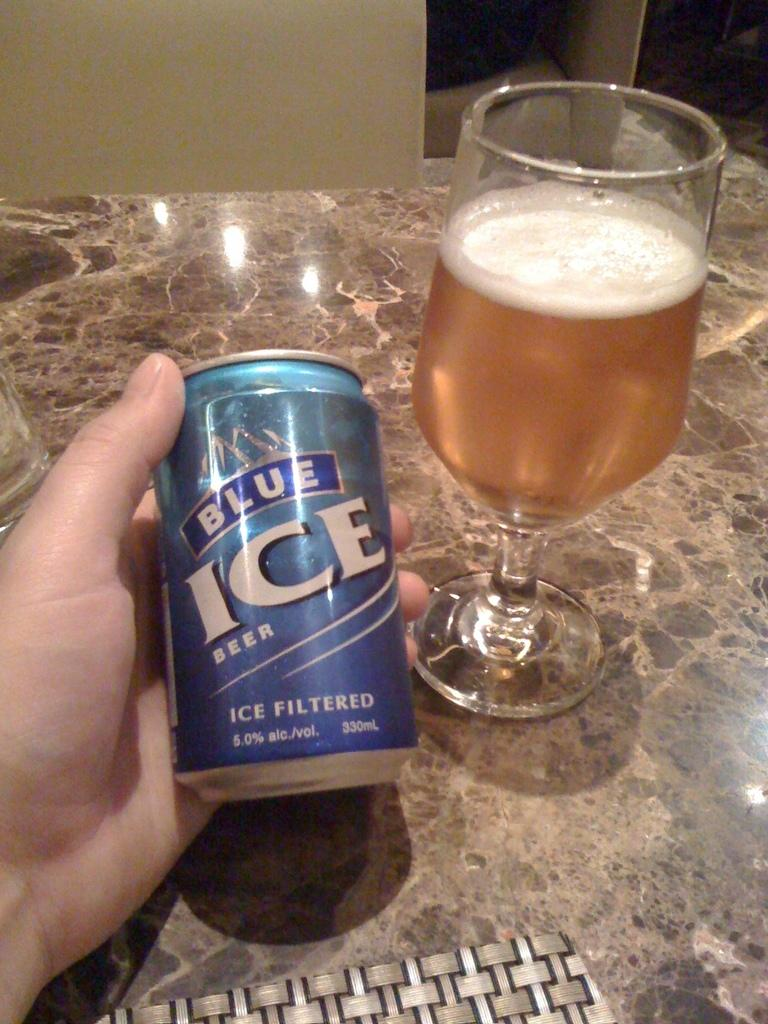<image>
Provide a brief description of the given image. A can of Blue Ice beer being held in a hand next to a glass of beer. 